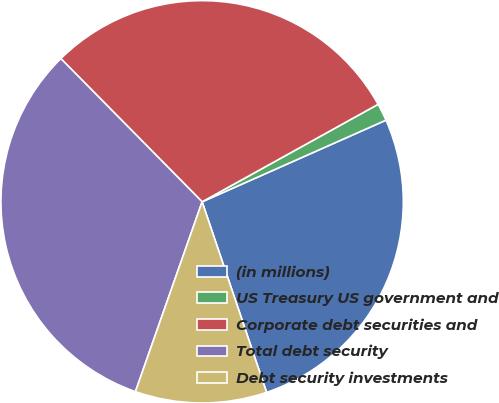<chart> <loc_0><loc_0><loc_500><loc_500><pie_chart><fcel>(in millions)<fcel>US Treasury US government and<fcel>Corporate debt securities and<fcel>Total debt security<fcel>Debt security investments<nl><fcel>26.46%<fcel>1.4%<fcel>29.34%<fcel>32.23%<fcel>10.57%<nl></chart> 